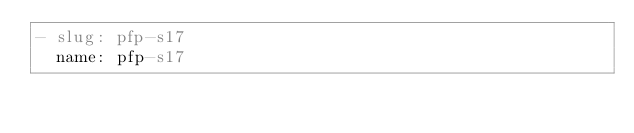Convert code to text. <code><loc_0><loc_0><loc_500><loc_500><_YAML_>- slug: pfp-s17
  name: pfp-s17
</code> 